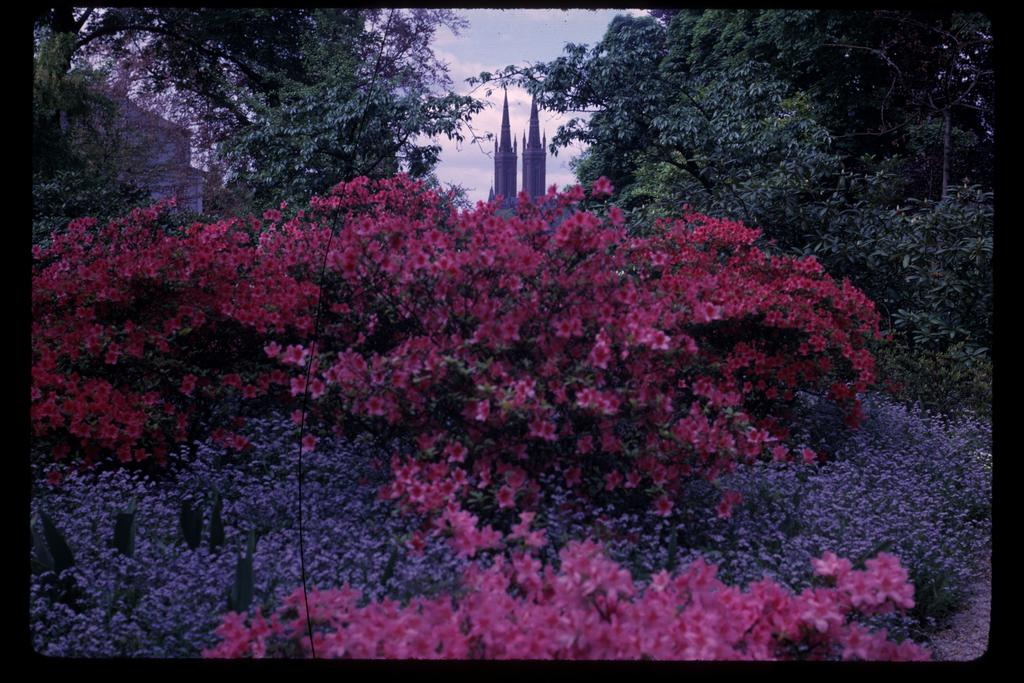What type of plants can be seen in the image? There are flower plants in the image. What structures are located in the middle of the image? There are big buildings in the middle of the image. What type of vegetation is on either side of the image? There are trees on either side of the image. What type of beef is being served in the image? There is no beef present in the image; it features flower plants, big buildings, and trees. What kind of underwear can be seen on the trees in the image? There is no underwear present in the image; it features flower plants, big buildings, and trees. 